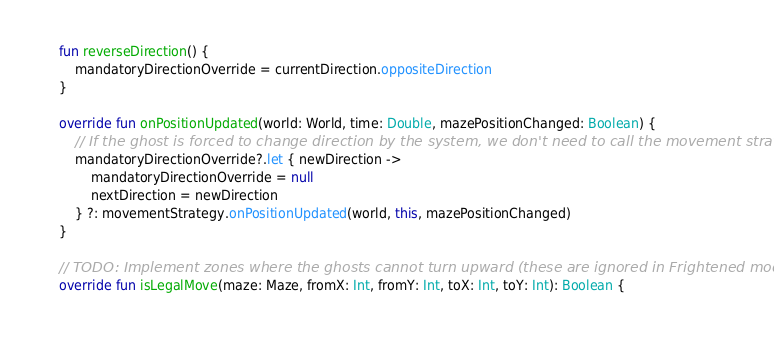<code> <loc_0><loc_0><loc_500><loc_500><_Kotlin_>    fun reverseDirection() {
        mandatoryDirectionOverride = currentDirection.oppositeDirection
    }

    override fun onPositionUpdated(world: World, time: Double, mazePositionChanged: Boolean) {
        // If the ghost is forced to change direction by the system, we don't need to call the movement strategy
        mandatoryDirectionOverride?.let { newDirection ->
            mandatoryDirectionOverride = null
            nextDirection = newDirection
        } ?: movementStrategy.onPositionUpdated(world, this, mazePositionChanged)
    }

    // TODO: Implement zones where the ghosts cannot turn upward (these are ignored in Frightened mode)
    override fun isLegalMove(maze: Maze, fromX: Int, fromY: Int, toX: Int, toY: Int): Boolean {</code> 